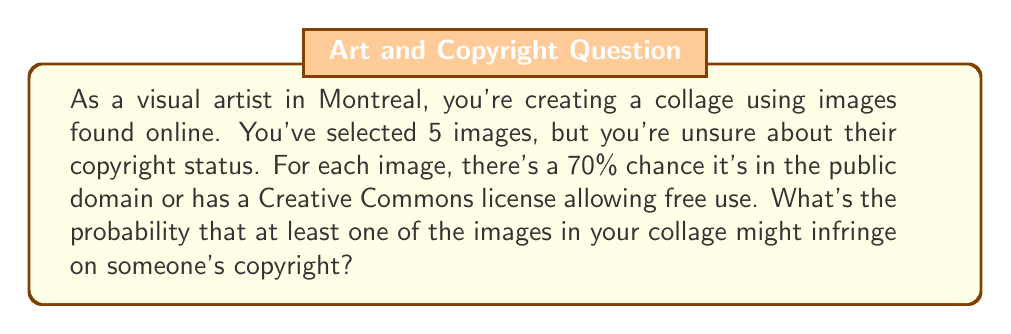What is the answer to this math problem? Let's approach this step-by-step:

1) First, let's define our events:
   Let A be the event that an image is safe to use (public domain or appropriate Creative Commons license).
   P(A) = 0.70

2) The probability that an image might infringe copyright is the complement of this:
   P(not A) = 1 - P(A) = 1 - 0.70 = 0.30

3) We want to find the probability that at least one image out of 5 might infringe. This is easier to calculate by finding the complement - the probability that none of the images infringe.

4) For no images to infringe, all 5 must be safe to use. The probability of this is:
   P(all safe) = $0.70^5 = 0.16807$

5) Therefore, the probability that at least one image might infringe is:
   P(at least one infringes) = 1 - P(all safe)
                              = $1 - 0.70^5$
                              = $1 - 0.16807$
                              = $0.83193$

6) Converting to a percentage:
   $0.83193 \times 100\% = 83.193\%$
Answer: The probability that at least one of the images in your collage might infringe on someone's copyright is approximately 83.19%. 